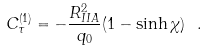<formula> <loc_0><loc_0><loc_500><loc_500>C ^ { ( 1 ) } _ { \tau } = - \frac { R _ { I I A } ^ { 2 } } { q _ { 0 } } ( 1 - \sinh \chi ) \ .</formula> 